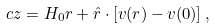Convert formula to latex. <formula><loc_0><loc_0><loc_500><loc_500>c z = H _ { 0 } r + \hat { r } \cdot \left [ v ( r ) - v ( { 0 } ) \right ] ,</formula> 